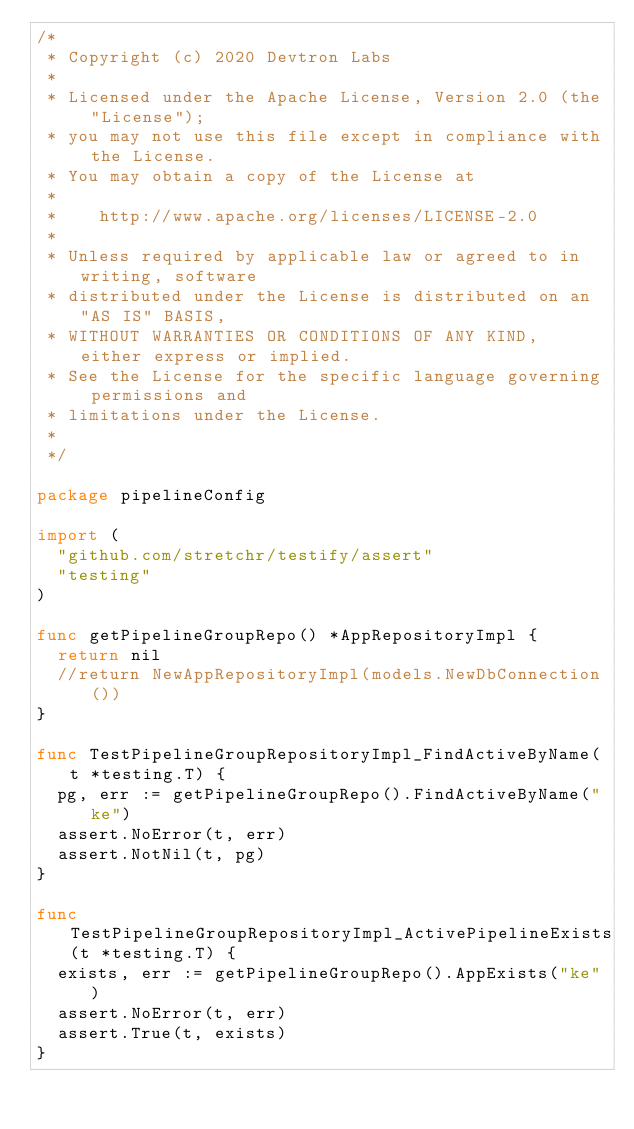Convert code to text. <code><loc_0><loc_0><loc_500><loc_500><_Go_>/*
 * Copyright (c) 2020 Devtron Labs
 *
 * Licensed under the Apache License, Version 2.0 (the "License");
 * you may not use this file except in compliance with the License.
 * You may obtain a copy of the License at
 *
 *    http://www.apache.org/licenses/LICENSE-2.0
 *
 * Unless required by applicable law or agreed to in writing, software
 * distributed under the License is distributed on an "AS IS" BASIS,
 * WITHOUT WARRANTIES OR CONDITIONS OF ANY KIND, either express or implied.
 * See the License for the specific language governing permissions and
 * limitations under the License.
 *
 */

package pipelineConfig

import (
	"github.com/stretchr/testify/assert"
	"testing"
)

func getPipelineGroupRepo() *AppRepositoryImpl {
	return nil
	//return NewAppRepositoryImpl(models.NewDbConnection())
}

func TestPipelineGroupRepositoryImpl_FindActiveByName(t *testing.T) {
	pg, err := getPipelineGroupRepo().FindActiveByName("ke")
	assert.NoError(t, err)
	assert.NotNil(t, pg)
}

func TestPipelineGroupRepositoryImpl_ActivePipelineExists(t *testing.T) {
	exists, err := getPipelineGroupRepo().AppExists("ke")
	assert.NoError(t, err)
	assert.True(t, exists)
}
</code> 